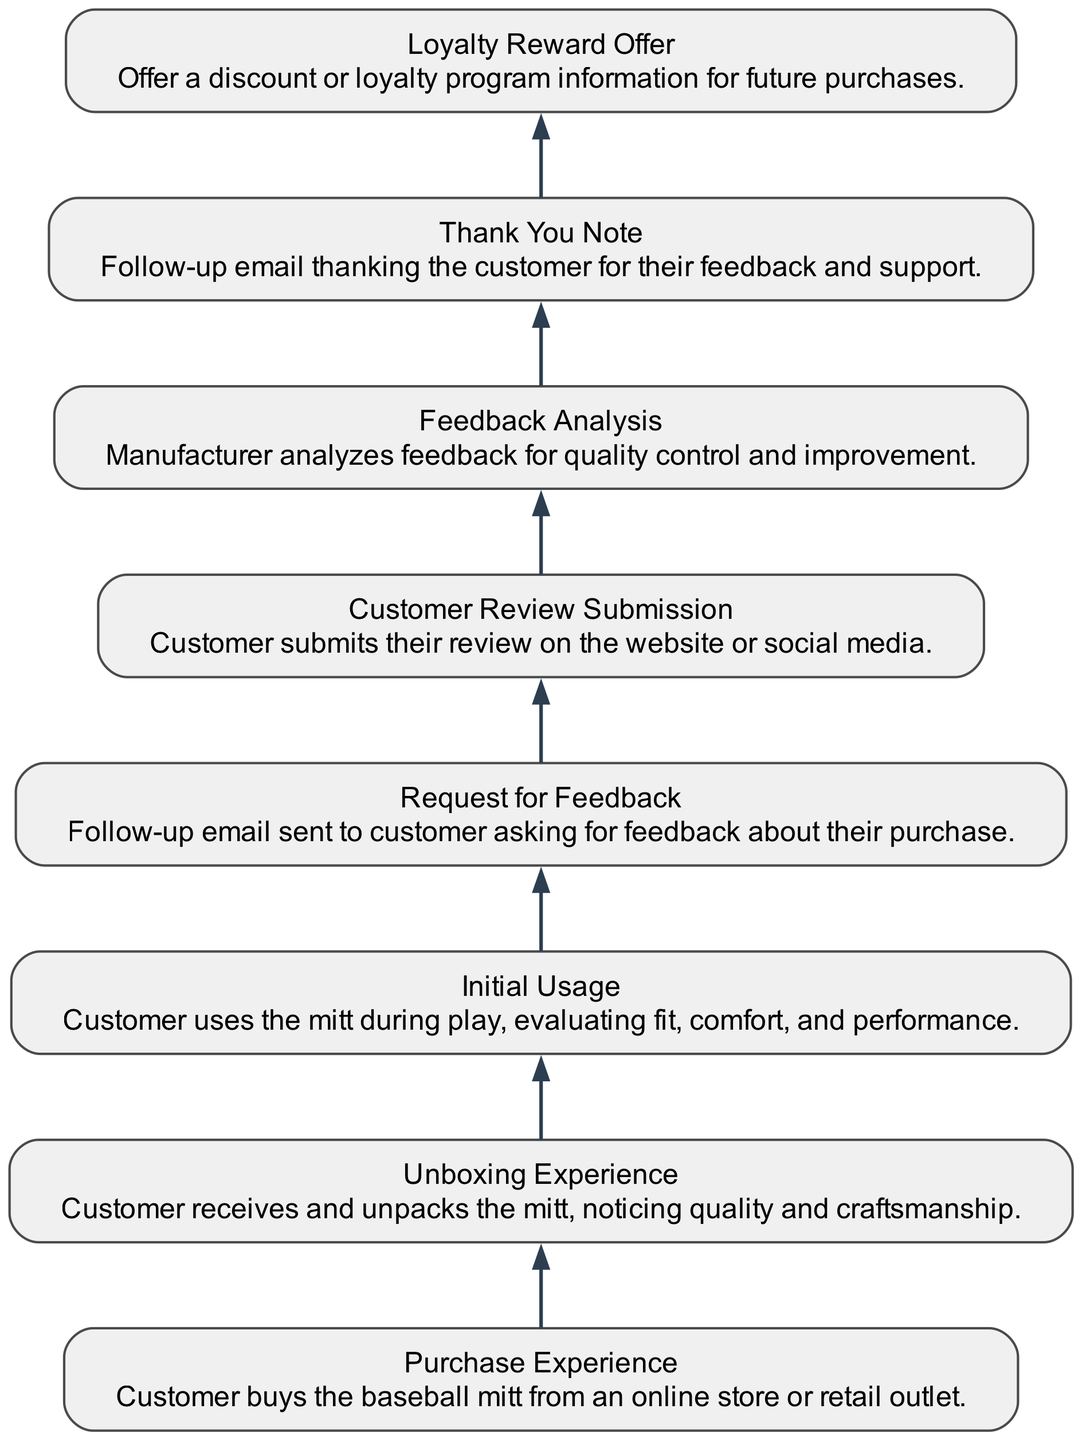What is the first step in the customer feedback flow? The diagram starts with the "Purchase Experience" node, indicating that this is the initial step when customers buy the baseball mitt.
Answer: Purchase Experience How many nodes are present in the diagram? By counting each distinct element listed in the diagram, there are a total of eight nodes representing the various stages of the customer feedback flow.
Answer: 8 Which node follows "Initial Usage"? The "Feedback Request" node directly follows "Initial Usage" in the flow sequence, indicating that the request for feedback comes after the customer has used the mitt for the first time.
Answer: Request for Feedback What action is taken after the customer submits their review? The next action after "Customer Review Submission" is "Feedback Analysis," where the manufacturer evaluates the received feedback for improvements.
Answer: Feedback Analysis What type of action is "Thank You Note"? The "Thank You Note" is a follow-up action that expresses gratitude to the customer for their feedback, making it a customer engagement effort to maintain relationships.
Answer: Follow-up action Which node is linked to "Unboxing Experience"? The "Initial Usage" node is linked to "Unboxing Experience," indicating that after the customer unboxes the mitt, they will go on to use it for the first time.
Answer: Initial Usage What is the last step in the flow? The last step in the customer feedback flow is the "Loyalty Reward Offer," where the manufacturer incentivizes repeat purchases through discounts or loyalty information.
Answer: Loyalty Reward Offer What links the "Request for Feedback" and "Customer Review Submission"? The flow directly moves from "Request for Feedback" to "Customer Review Submission," indicating that the customer is expected to provide their review after receiving the feedback request.
Answer: Customer Review Submission Which two steps are the most connected in this diagram? Analyzing the flow, the steps "Feedback Analysis" and "Thank You Note" are closely interconnected, as the analysis directly leads into sending a thank-you message.
Answer: Feedback Analysis and Thank You Note 